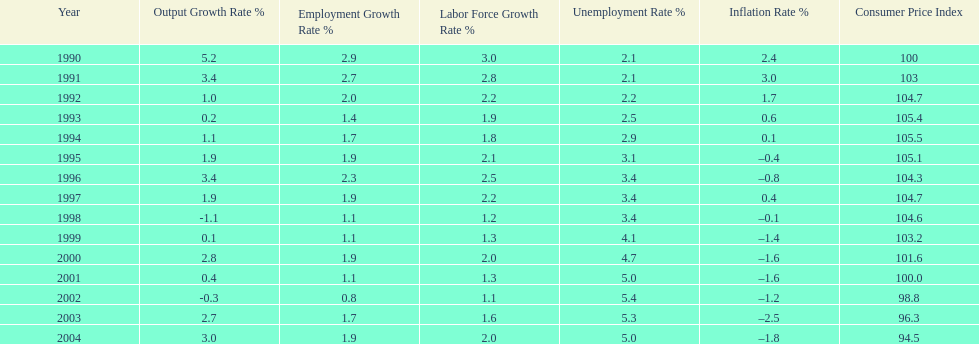When in the 1990's did the inflation rate first become negative? 1995. 